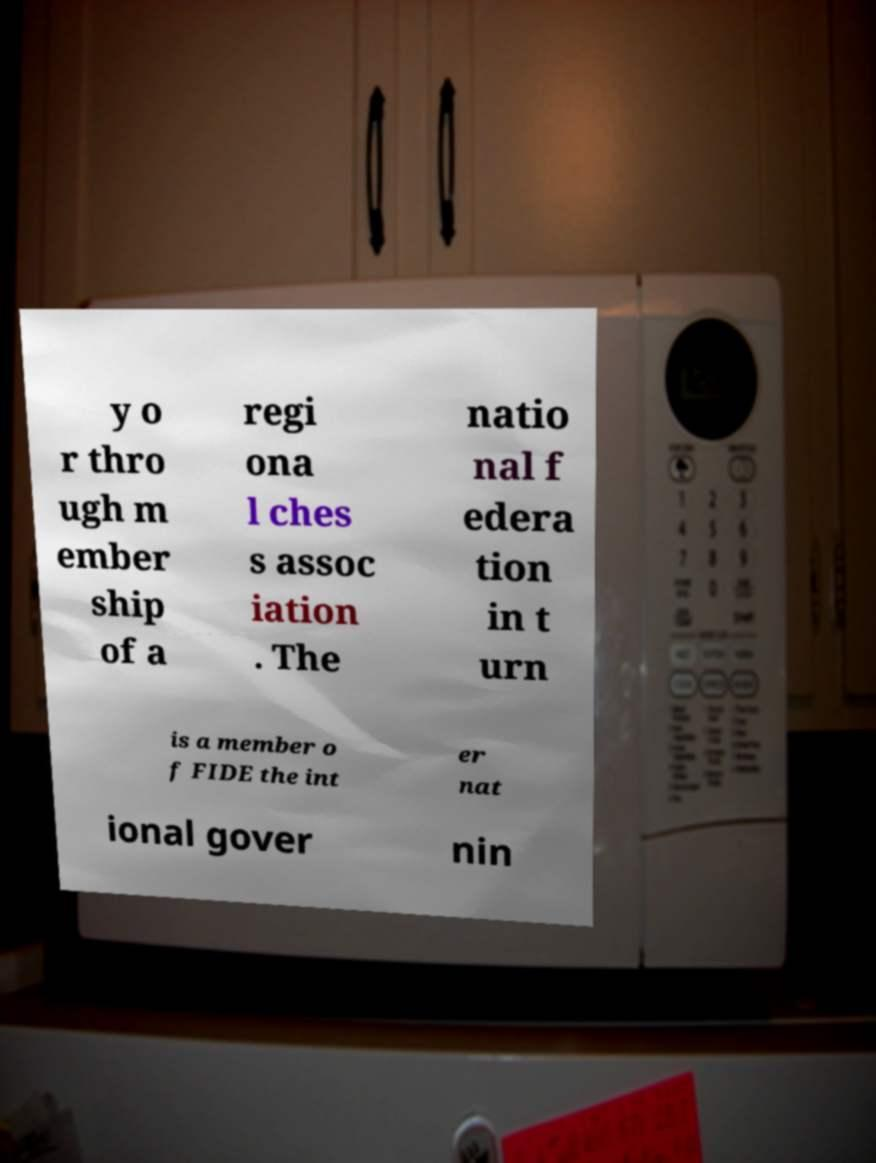Can you accurately transcribe the text from the provided image for me? y o r thro ugh m ember ship of a regi ona l ches s assoc iation . The natio nal f edera tion in t urn is a member o f FIDE the int er nat ional gover nin 